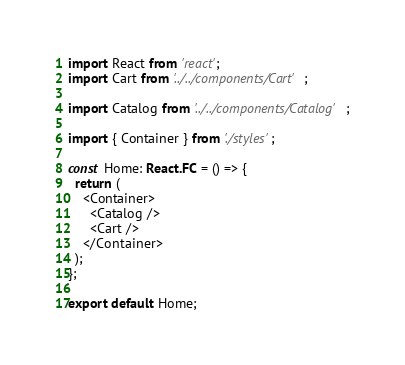<code> <loc_0><loc_0><loc_500><loc_500><_TypeScript_>import React from 'react';
import Cart from '../../components/Cart';

import Catalog from '../../components/Catalog';

import { Container } from './styles';

const Home: React.FC = () => {
  return (
    <Container>
      <Catalog />
      <Cart />
    </Container>
  );
};

export default Home;
</code> 